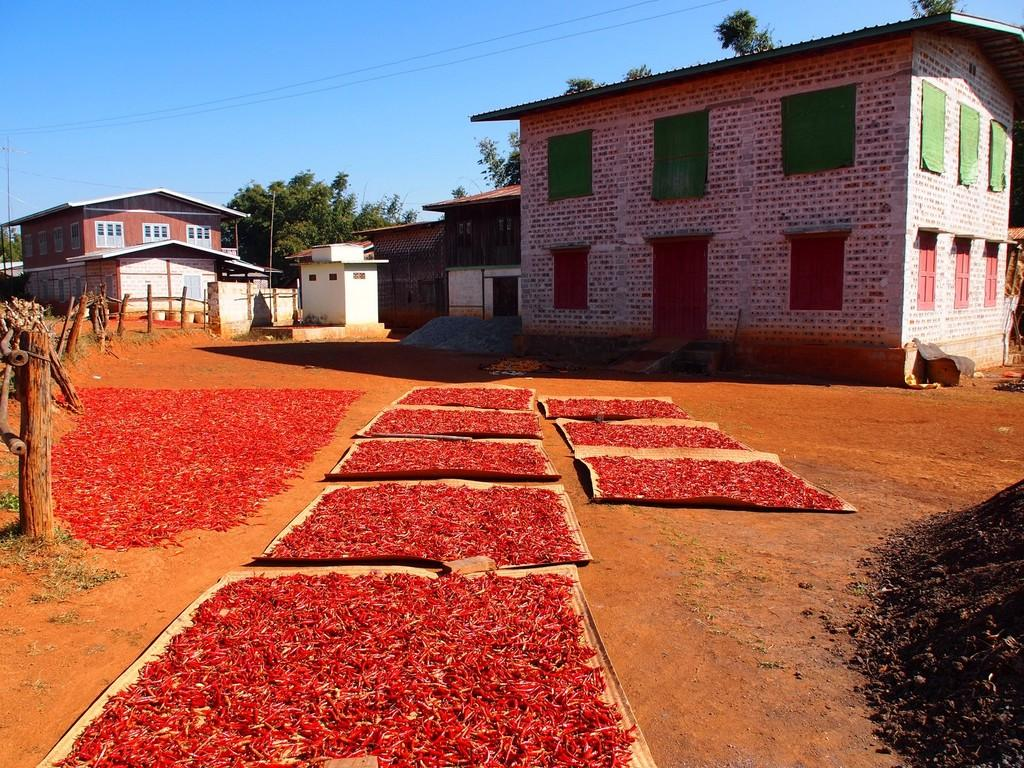What type of food item can be seen in the image? There are red chillies in the image. What can be seen beneath the chillies in the image? The ground is visible in the image. What type of barrier is present in the image? There is a wooden fence in the image. What type of structures are visible in the image? There are houses in the image. What type of vegetation is present in the image? There are trees in the image. What is visible in the background of the image? The sky is visible in the background of the image. How many children are playing in the image? There are no children present in the image. 